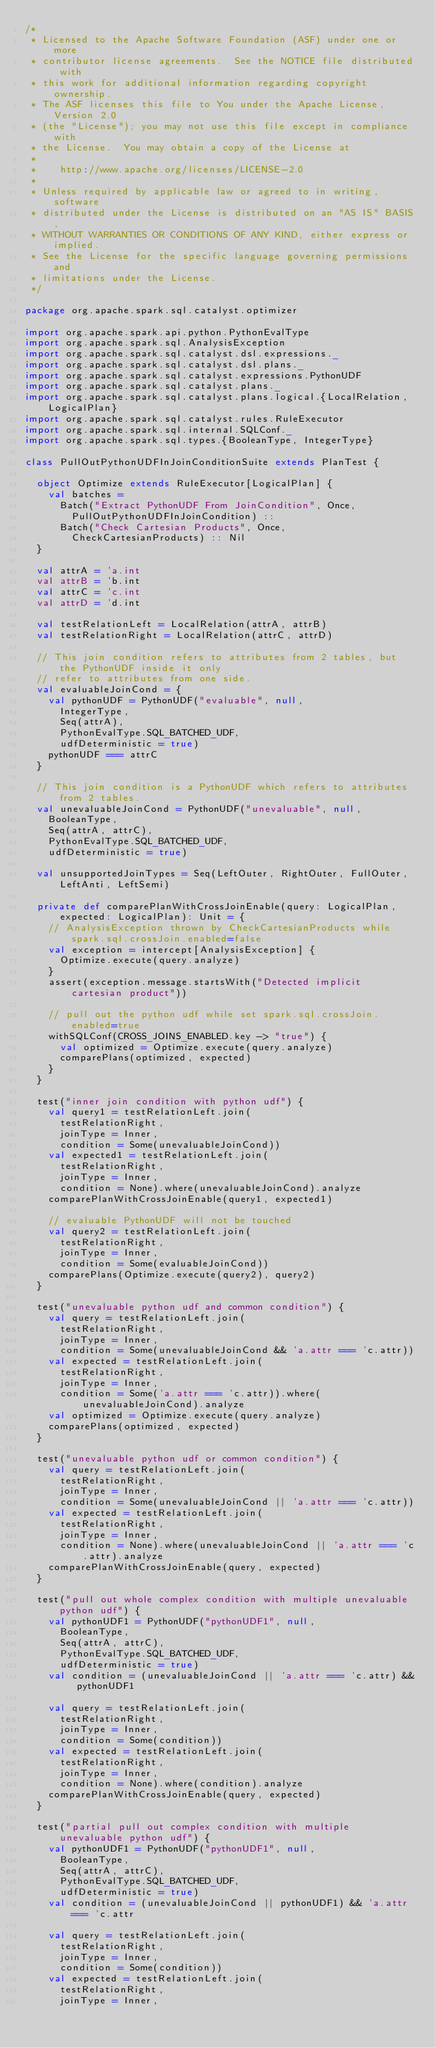<code> <loc_0><loc_0><loc_500><loc_500><_Scala_>/*
 * Licensed to the Apache Software Foundation (ASF) under one or more
 * contributor license agreements.  See the NOTICE file distributed with
 * this work for additional information regarding copyright ownership.
 * The ASF licenses this file to You under the Apache License, Version 2.0
 * (the "License"); you may not use this file except in compliance with
 * the License.  You may obtain a copy of the License at
 *
 *    http://www.apache.org/licenses/LICENSE-2.0
 *
 * Unless required by applicable law or agreed to in writing, software
 * distributed under the License is distributed on an "AS IS" BASIS,
 * WITHOUT WARRANTIES OR CONDITIONS OF ANY KIND, either express or implied.
 * See the License for the specific language governing permissions and
 * limitations under the License.
 */

package org.apache.spark.sql.catalyst.optimizer

import org.apache.spark.api.python.PythonEvalType
import org.apache.spark.sql.AnalysisException
import org.apache.spark.sql.catalyst.dsl.expressions._
import org.apache.spark.sql.catalyst.dsl.plans._
import org.apache.spark.sql.catalyst.expressions.PythonUDF
import org.apache.spark.sql.catalyst.plans._
import org.apache.spark.sql.catalyst.plans.logical.{LocalRelation, LogicalPlan}
import org.apache.spark.sql.catalyst.rules.RuleExecutor
import org.apache.spark.sql.internal.SQLConf._
import org.apache.spark.sql.types.{BooleanType, IntegerType}

class PullOutPythonUDFInJoinConditionSuite extends PlanTest {

  object Optimize extends RuleExecutor[LogicalPlan] {
    val batches =
      Batch("Extract PythonUDF From JoinCondition", Once,
        PullOutPythonUDFInJoinCondition) ::
      Batch("Check Cartesian Products", Once,
        CheckCartesianProducts) :: Nil
  }

  val attrA = 'a.int
  val attrB = 'b.int
  val attrC = 'c.int
  val attrD = 'd.int

  val testRelationLeft = LocalRelation(attrA, attrB)
  val testRelationRight = LocalRelation(attrC, attrD)

  // This join condition refers to attributes from 2 tables, but the PythonUDF inside it only
  // refer to attributes from one side.
  val evaluableJoinCond = {
    val pythonUDF = PythonUDF("evaluable", null,
      IntegerType,
      Seq(attrA),
      PythonEvalType.SQL_BATCHED_UDF,
      udfDeterministic = true)
    pythonUDF === attrC
  }

  // This join condition is a PythonUDF which refers to attributes from 2 tables.
  val unevaluableJoinCond = PythonUDF("unevaluable", null,
    BooleanType,
    Seq(attrA, attrC),
    PythonEvalType.SQL_BATCHED_UDF,
    udfDeterministic = true)

  val unsupportedJoinTypes = Seq(LeftOuter, RightOuter, FullOuter, LeftAnti, LeftSemi)

  private def comparePlanWithCrossJoinEnable(query: LogicalPlan, expected: LogicalPlan): Unit = {
    // AnalysisException thrown by CheckCartesianProducts while spark.sql.crossJoin.enabled=false
    val exception = intercept[AnalysisException] {
      Optimize.execute(query.analyze)
    }
    assert(exception.message.startsWith("Detected implicit cartesian product"))

    // pull out the python udf while set spark.sql.crossJoin.enabled=true
    withSQLConf(CROSS_JOINS_ENABLED.key -> "true") {
      val optimized = Optimize.execute(query.analyze)
      comparePlans(optimized, expected)
    }
  }

  test("inner join condition with python udf") {
    val query1 = testRelationLeft.join(
      testRelationRight,
      joinType = Inner,
      condition = Some(unevaluableJoinCond))
    val expected1 = testRelationLeft.join(
      testRelationRight,
      joinType = Inner,
      condition = None).where(unevaluableJoinCond).analyze
    comparePlanWithCrossJoinEnable(query1, expected1)

    // evaluable PythonUDF will not be touched
    val query2 = testRelationLeft.join(
      testRelationRight,
      joinType = Inner,
      condition = Some(evaluableJoinCond))
    comparePlans(Optimize.execute(query2), query2)
  }

  test("unevaluable python udf and common condition") {
    val query = testRelationLeft.join(
      testRelationRight,
      joinType = Inner,
      condition = Some(unevaluableJoinCond && 'a.attr === 'c.attr))
    val expected = testRelationLeft.join(
      testRelationRight,
      joinType = Inner,
      condition = Some('a.attr === 'c.attr)).where(unevaluableJoinCond).analyze
    val optimized = Optimize.execute(query.analyze)
    comparePlans(optimized, expected)
  }

  test("unevaluable python udf or common condition") {
    val query = testRelationLeft.join(
      testRelationRight,
      joinType = Inner,
      condition = Some(unevaluableJoinCond || 'a.attr === 'c.attr))
    val expected = testRelationLeft.join(
      testRelationRight,
      joinType = Inner,
      condition = None).where(unevaluableJoinCond || 'a.attr === 'c.attr).analyze
    comparePlanWithCrossJoinEnable(query, expected)
  }

  test("pull out whole complex condition with multiple unevaluable python udf") {
    val pythonUDF1 = PythonUDF("pythonUDF1", null,
      BooleanType,
      Seq(attrA, attrC),
      PythonEvalType.SQL_BATCHED_UDF,
      udfDeterministic = true)
    val condition = (unevaluableJoinCond || 'a.attr === 'c.attr) && pythonUDF1

    val query = testRelationLeft.join(
      testRelationRight,
      joinType = Inner,
      condition = Some(condition))
    val expected = testRelationLeft.join(
      testRelationRight,
      joinType = Inner,
      condition = None).where(condition).analyze
    comparePlanWithCrossJoinEnable(query, expected)
  }

  test("partial pull out complex condition with multiple unevaluable python udf") {
    val pythonUDF1 = PythonUDF("pythonUDF1", null,
      BooleanType,
      Seq(attrA, attrC),
      PythonEvalType.SQL_BATCHED_UDF,
      udfDeterministic = true)
    val condition = (unevaluableJoinCond || pythonUDF1) && 'a.attr === 'c.attr

    val query = testRelationLeft.join(
      testRelationRight,
      joinType = Inner,
      condition = Some(condition))
    val expected = testRelationLeft.join(
      testRelationRight,
      joinType = Inner,</code> 